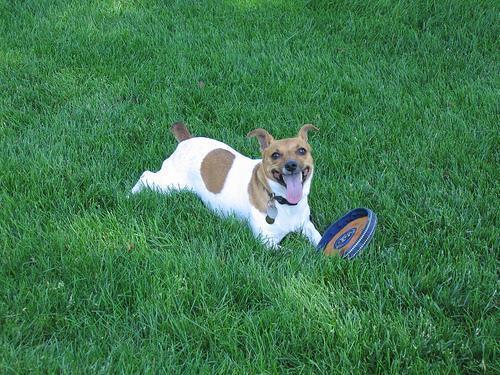How many people are present?
Give a very brief answer. 0. 